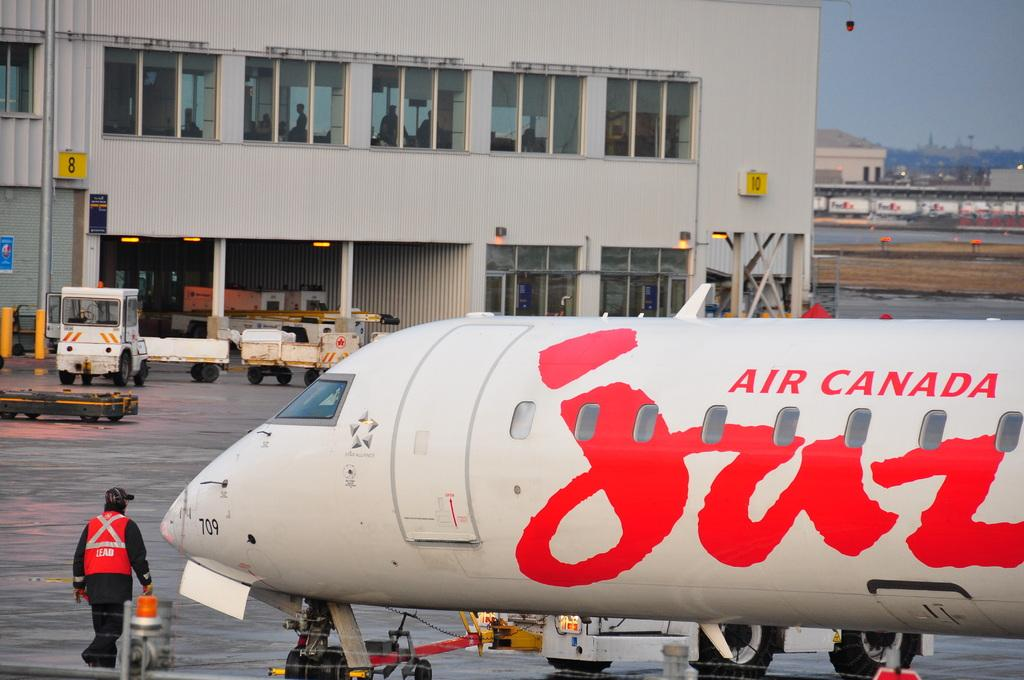<image>
Describe the image concisely. A worker walks in front of an Air Canada airplane. 